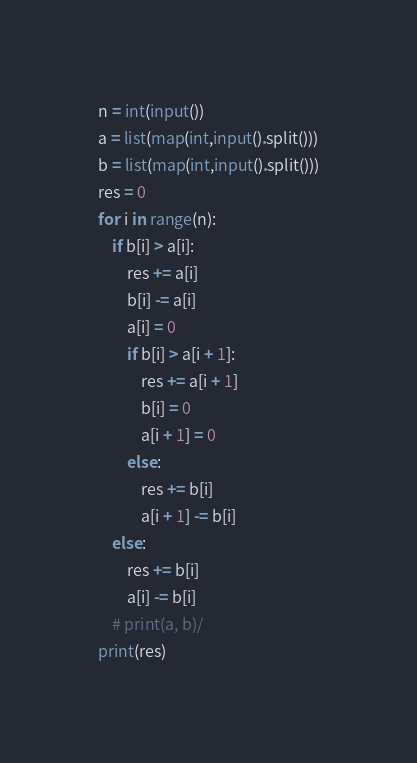<code> <loc_0><loc_0><loc_500><loc_500><_Python_>n = int(input())
a = list(map(int,input().split()))
b = list(map(int,input().split()))
res = 0
for i in range(n):
    if b[i] > a[i]:
        res += a[i]
        b[i] -= a[i]
        a[i] = 0
        if b[i] > a[i + 1]:
            res += a[i + 1]
            b[i] = 0
            a[i + 1] = 0
        else:
            res += b[i]
            a[i + 1] -= b[i]
    else:
        res += b[i]
        a[i] -= b[i]
    # print(a, b)/
print(res)</code> 